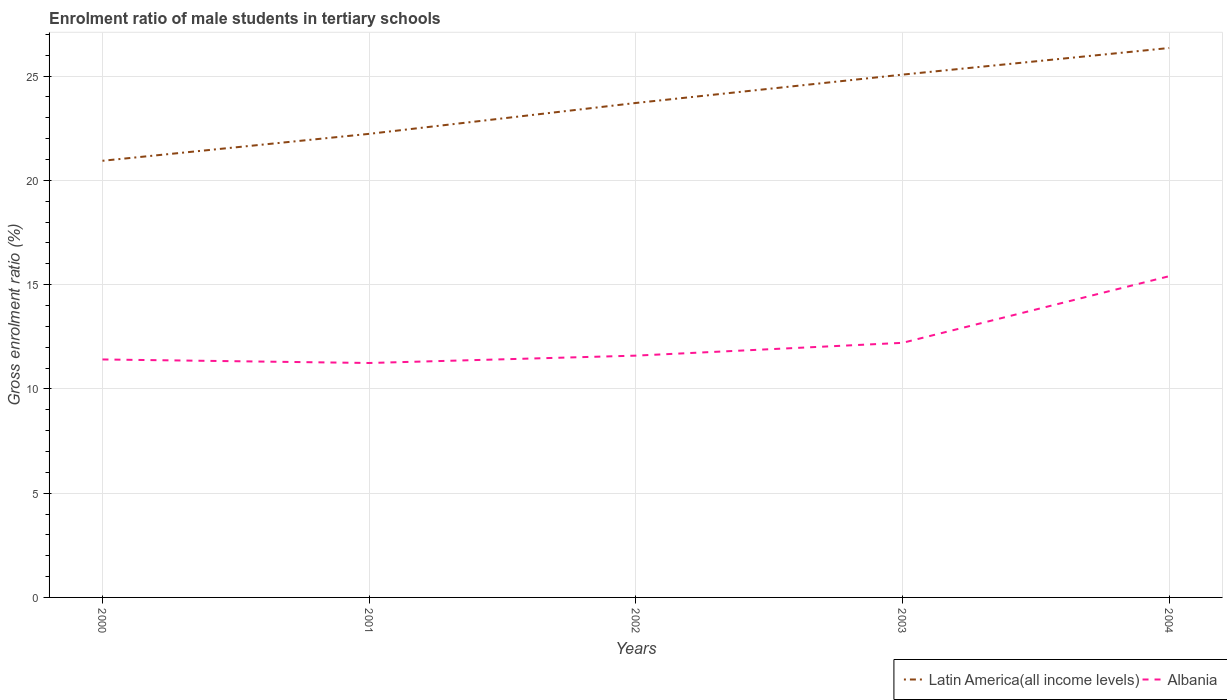Is the number of lines equal to the number of legend labels?
Give a very brief answer. Yes. Across all years, what is the maximum enrolment ratio of male students in tertiary schools in Latin America(all income levels)?
Offer a very short reply. 20.94. In which year was the enrolment ratio of male students in tertiary schools in Latin America(all income levels) maximum?
Keep it short and to the point. 2000. What is the total enrolment ratio of male students in tertiary schools in Latin America(all income levels) in the graph?
Provide a short and direct response. -1.48. What is the difference between the highest and the second highest enrolment ratio of male students in tertiary schools in Latin America(all income levels)?
Offer a very short reply. 5.41. What is the difference between the highest and the lowest enrolment ratio of male students in tertiary schools in Latin America(all income levels)?
Make the answer very short. 3. Does the graph contain any zero values?
Offer a very short reply. No. Does the graph contain grids?
Keep it short and to the point. Yes. Where does the legend appear in the graph?
Provide a succinct answer. Bottom right. How are the legend labels stacked?
Your answer should be very brief. Horizontal. What is the title of the graph?
Your answer should be very brief. Enrolment ratio of male students in tertiary schools. What is the label or title of the X-axis?
Keep it short and to the point. Years. What is the Gross enrolment ratio (%) of Latin America(all income levels) in 2000?
Provide a short and direct response. 20.94. What is the Gross enrolment ratio (%) in Albania in 2000?
Provide a succinct answer. 11.41. What is the Gross enrolment ratio (%) in Latin America(all income levels) in 2001?
Ensure brevity in your answer.  22.23. What is the Gross enrolment ratio (%) in Albania in 2001?
Provide a succinct answer. 11.24. What is the Gross enrolment ratio (%) of Latin America(all income levels) in 2002?
Keep it short and to the point. 23.71. What is the Gross enrolment ratio (%) in Albania in 2002?
Provide a short and direct response. 11.59. What is the Gross enrolment ratio (%) in Latin America(all income levels) in 2003?
Give a very brief answer. 25.07. What is the Gross enrolment ratio (%) of Albania in 2003?
Offer a very short reply. 12.21. What is the Gross enrolment ratio (%) of Latin America(all income levels) in 2004?
Your response must be concise. 26.34. What is the Gross enrolment ratio (%) in Albania in 2004?
Offer a very short reply. 15.4. Across all years, what is the maximum Gross enrolment ratio (%) of Latin America(all income levels)?
Make the answer very short. 26.34. Across all years, what is the maximum Gross enrolment ratio (%) of Albania?
Make the answer very short. 15.4. Across all years, what is the minimum Gross enrolment ratio (%) of Latin America(all income levels)?
Provide a short and direct response. 20.94. Across all years, what is the minimum Gross enrolment ratio (%) of Albania?
Offer a terse response. 11.24. What is the total Gross enrolment ratio (%) in Latin America(all income levels) in the graph?
Ensure brevity in your answer.  118.29. What is the total Gross enrolment ratio (%) in Albania in the graph?
Your answer should be very brief. 61.86. What is the difference between the Gross enrolment ratio (%) of Latin America(all income levels) in 2000 and that in 2001?
Give a very brief answer. -1.29. What is the difference between the Gross enrolment ratio (%) of Albania in 2000 and that in 2001?
Provide a succinct answer. 0.17. What is the difference between the Gross enrolment ratio (%) in Latin America(all income levels) in 2000 and that in 2002?
Offer a terse response. -2.77. What is the difference between the Gross enrolment ratio (%) of Albania in 2000 and that in 2002?
Give a very brief answer. -0.18. What is the difference between the Gross enrolment ratio (%) in Latin America(all income levels) in 2000 and that in 2003?
Your answer should be very brief. -4.13. What is the difference between the Gross enrolment ratio (%) in Albania in 2000 and that in 2003?
Give a very brief answer. -0.8. What is the difference between the Gross enrolment ratio (%) in Latin America(all income levels) in 2000 and that in 2004?
Offer a very short reply. -5.41. What is the difference between the Gross enrolment ratio (%) in Albania in 2000 and that in 2004?
Ensure brevity in your answer.  -3.99. What is the difference between the Gross enrolment ratio (%) in Latin America(all income levels) in 2001 and that in 2002?
Your answer should be very brief. -1.48. What is the difference between the Gross enrolment ratio (%) of Albania in 2001 and that in 2002?
Offer a terse response. -0.35. What is the difference between the Gross enrolment ratio (%) of Latin America(all income levels) in 2001 and that in 2003?
Give a very brief answer. -2.84. What is the difference between the Gross enrolment ratio (%) of Albania in 2001 and that in 2003?
Provide a succinct answer. -0.97. What is the difference between the Gross enrolment ratio (%) in Latin America(all income levels) in 2001 and that in 2004?
Ensure brevity in your answer.  -4.12. What is the difference between the Gross enrolment ratio (%) of Albania in 2001 and that in 2004?
Provide a succinct answer. -4.16. What is the difference between the Gross enrolment ratio (%) in Latin America(all income levels) in 2002 and that in 2003?
Offer a very short reply. -1.36. What is the difference between the Gross enrolment ratio (%) of Albania in 2002 and that in 2003?
Provide a short and direct response. -0.61. What is the difference between the Gross enrolment ratio (%) of Latin America(all income levels) in 2002 and that in 2004?
Ensure brevity in your answer.  -2.64. What is the difference between the Gross enrolment ratio (%) of Albania in 2002 and that in 2004?
Provide a short and direct response. -3.81. What is the difference between the Gross enrolment ratio (%) in Latin America(all income levels) in 2003 and that in 2004?
Your answer should be compact. -1.28. What is the difference between the Gross enrolment ratio (%) in Albania in 2003 and that in 2004?
Make the answer very short. -3.2. What is the difference between the Gross enrolment ratio (%) of Latin America(all income levels) in 2000 and the Gross enrolment ratio (%) of Albania in 2001?
Ensure brevity in your answer.  9.7. What is the difference between the Gross enrolment ratio (%) of Latin America(all income levels) in 2000 and the Gross enrolment ratio (%) of Albania in 2002?
Your response must be concise. 9.34. What is the difference between the Gross enrolment ratio (%) of Latin America(all income levels) in 2000 and the Gross enrolment ratio (%) of Albania in 2003?
Provide a succinct answer. 8.73. What is the difference between the Gross enrolment ratio (%) of Latin America(all income levels) in 2000 and the Gross enrolment ratio (%) of Albania in 2004?
Offer a very short reply. 5.53. What is the difference between the Gross enrolment ratio (%) of Latin America(all income levels) in 2001 and the Gross enrolment ratio (%) of Albania in 2002?
Your answer should be very brief. 10.63. What is the difference between the Gross enrolment ratio (%) in Latin America(all income levels) in 2001 and the Gross enrolment ratio (%) in Albania in 2003?
Offer a terse response. 10.02. What is the difference between the Gross enrolment ratio (%) in Latin America(all income levels) in 2001 and the Gross enrolment ratio (%) in Albania in 2004?
Provide a succinct answer. 6.83. What is the difference between the Gross enrolment ratio (%) in Latin America(all income levels) in 2002 and the Gross enrolment ratio (%) in Albania in 2003?
Give a very brief answer. 11.5. What is the difference between the Gross enrolment ratio (%) in Latin America(all income levels) in 2002 and the Gross enrolment ratio (%) in Albania in 2004?
Provide a short and direct response. 8.31. What is the difference between the Gross enrolment ratio (%) of Latin America(all income levels) in 2003 and the Gross enrolment ratio (%) of Albania in 2004?
Your response must be concise. 9.66. What is the average Gross enrolment ratio (%) of Latin America(all income levels) per year?
Your answer should be very brief. 23.66. What is the average Gross enrolment ratio (%) in Albania per year?
Your answer should be very brief. 12.37. In the year 2000, what is the difference between the Gross enrolment ratio (%) of Latin America(all income levels) and Gross enrolment ratio (%) of Albania?
Your answer should be compact. 9.53. In the year 2001, what is the difference between the Gross enrolment ratio (%) in Latin America(all income levels) and Gross enrolment ratio (%) in Albania?
Keep it short and to the point. 10.99. In the year 2002, what is the difference between the Gross enrolment ratio (%) in Latin America(all income levels) and Gross enrolment ratio (%) in Albania?
Offer a very short reply. 12.11. In the year 2003, what is the difference between the Gross enrolment ratio (%) of Latin America(all income levels) and Gross enrolment ratio (%) of Albania?
Offer a terse response. 12.86. In the year 2004, what is the difference between the Gross enrolment ratio (%) in Latin America(all income levels) and Gross enrolment ratio (%) in Albania?
Give a very brief answer. 10.94. What is the ratio of the Gross enrolment ratio (%) of Latin America(all income levels) in 2000 to that in 2001?
Ensure brevity in your answer.  0.94. What is the ratio of the Gross enrolment ratio (%) of Albania in 2000 to that in 2001?
Offer a very short reply. 1.02. What is the ratio of the Gross enrolment ratio (%) in Latin America(all income levels) in 2000 to that in 2002?
Ensure brevity in your answer.  0.88. What is the ratio of the Gross enrolment ratio (%) in Albania in 2000 to that in 2002?
Your response must be concise. 0.98. What is the ratio of the Gross enrolment ratio (%) in Latin America(all income levels) in 2000 to that in 2003?
Give a very brief answer. 0.84. What is the ratio of the Gross enrolment ratio (%) of Albania in 2000 to that in 2003?
Your answer should be compact. 0.93. What is the ratio of the Gross enrolment ratio (%) in Latin America(all income levels) in 2000 to that in 2004?
Keep it short and to the point. 0.79. What is the ratio of the Gross enrolment ratio (%) of Albania in 2000 to that in 2004?
Provide a succinct answer. 0.74. What is the ratio of the Gross enrolment ratio (%) in Latin America(all income levels) in 2001 to that in 2002?
Your response must be concise. 0.94. What is the ratio of the Gross enrolment ratio (%) of Albania in 2001 to that in 2002?
Provide a short and direct response. 0.97. What is the ratio of the Gross enrolment ratio (%) in Latin America(all income levels) in 2001 to that in 2003?
Keep it short and to the point. 0.89. What is the ratio of the Gross enrolment ratio (%) of Albania in 2001 to that in 2003?
Offer a very short reply. 0.92. What is the ratio of the Gross enrolment ratio (%) in Latin America(all income levels) in 2001 to that in 2004?
Offer a very short reply. 0.84. What is the ratio of the Gross enrolment ratio (%) in Albania in 2001 to that in 2004?
Give a very brief answer. 0.73. What is the ratio of the Gross enrolment ratio (%) of Latin America(all income levels) in 2002 to that in 2003?
Provide a short and direct response. 0.95. What is the ratio of the Gross enrolment ratio (%) in Albania in 2002 to that in 2003?
Your answer should be very brief. 0.95. What is the ratio of the Gross enrolment ratio (%) of Latin America(all income levels) in 2002 to that in 2004?
Provide a succinct answer. 0.9. What is the ratio of the Gross enrolment ratio (%) of Albania in 2002 to that in 2004?
Your answer should be compact. 0.75. What is the ratio of the Gross enrolment ratio (%) of Latin America(all income levels) in 2003 to that in 2004?
Offer a terse response. 0.95. What is the ratio of the Gross enrolment ratio (%) in Albania in 2003 to that in 2004?
Ensure brevity in your answer.  0.79. What is the difference between the highest and the second highest Gross enrolment ratio (%) of Latin America(all income levels)?
Provide a succinct answer. 1.28. What is the difference between the highest and the second highest Gross enrolment ratio (%) in Albania?
Offer a very short reply. 3.2. What is the difference between the highest and the lowest Gross enrolment ratio (%) in Latin America(all income levels)?
Your response must be concise. 5.41. What is the difference between the highest and the lowest Gross enrolment ratio (%) of Albania?
Give a very brief answer. 4.16. 